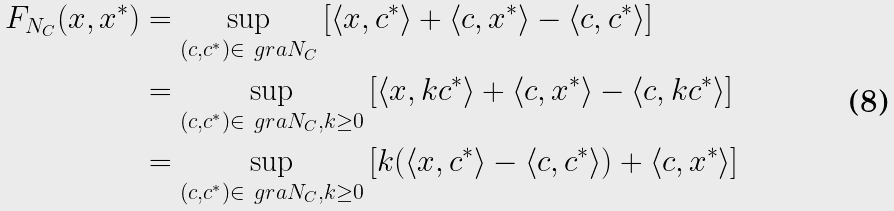Convert formula to latex. <formula><loc_0><loc_0><loc_500><loc_500>F _ { N _ { C } } ( x , x ^ { * } ) & = \sup _ { ( c , c ^ { * } ) \in \ g r a N _ { C } } \left [ \langle x , c ^ { * } \rangle + \langle c , x ^ { * } \rangle - \langle c , c ^ { * } \rangle \right ] \\ & = \sup _ { ( c , c ^ { * } ) \in \ g r a N _ { C } , k \geq 0 } \left [ \langle x , k c ^ { * } \rangle + \langle c , x ^ { * } \rangle - \langle c , k c ^ { * } \rangle \right ] \\ & = \sup _ { ( c , c ^ { * } ) \in \ g r a N _ { C } , k \geq 0 } \left [ k ( \langle x , c ^ { * } \rangle - \langle c , c ^ { * } \rangle ) + \langle c , x ^ { * } \rangle \right ]</formula> 